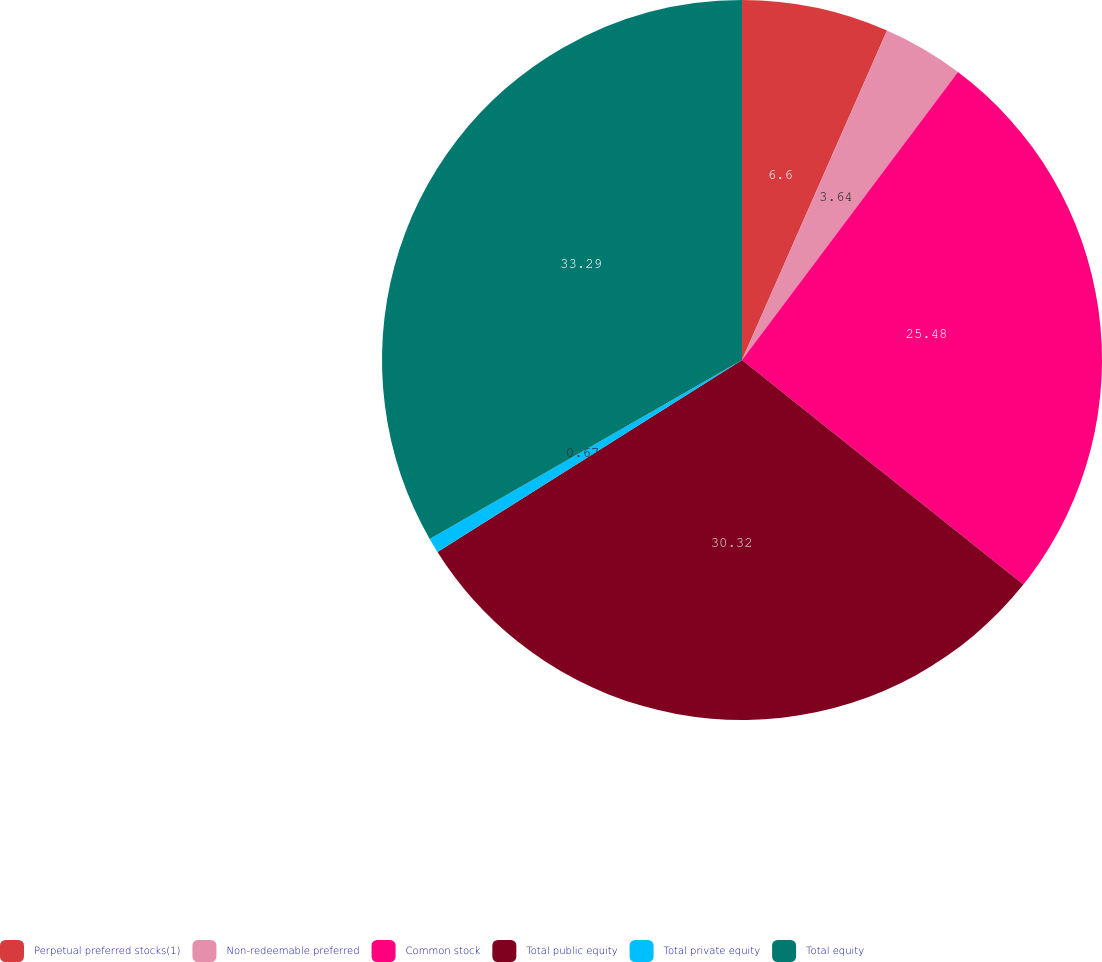Convert chart to OTSL. <chart><loc_0><loc_0><loc_500><loc_500><pie_chart><fcel>Perpetual preferred stocks(1)<fcel>Non-redeemable preferred<fcel>Common stock<fcel>Total public equity<fcel>Total private equity<fcel>Total equity<nl><fcel>6.6%<fcel>3.64%<fcel>25.48%<fcel>30.32%<fcel>0.67%<fcel>33.28%<nl></chart> 